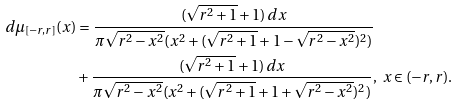<formula> <loc_0><loc_0><loc_500><loc_500>d \mu _ { [ - r , r ] } ( x ) & = \frac { ( \sqrt { r ^ { 2 } + 1 } + 1 ) \, d x } { \pi \sqrt { r ^ { 2 } - x ^ { 2 } } ( x ^ { 2 } + ( \sqrt { r ^ { 2 } + 1 } + 1 - \sqrt { r ^ { 2 } - x ^ { 2 } } ) ^ { 2 } ) } \\ & + \frac { ( \sqrt { r ^ { 2 } + 1 } + 1 ) \, d x } { \pi \sqrt { r ^ { 2 } - x ^ { 2 } } ( x ^ { 2 } + ( \sqrt { r ^ { 2 } + 1 } + 1 + \sqrt { r ^ { 2 } - x ^ { 2 } } ) ^ { 2 } ) } , \ x \in ( - r , r ) .</formula> 